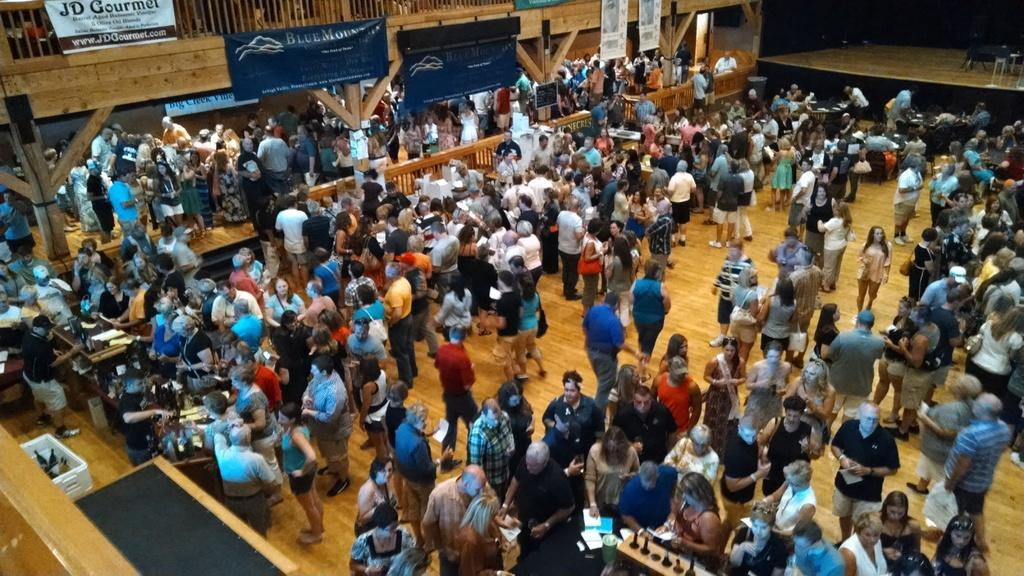How many people can be seen in the image? There are many people standing in the image. What is located at the top of the image? There is a railing with posters at the top of the image. What feature is present in the image that might be used for performances or speeches? There is a stage in the image. What type of soap is being used by the people in the image? There is no soap present in the image, as it features a crowd of people and a stage with a railing and posters. 